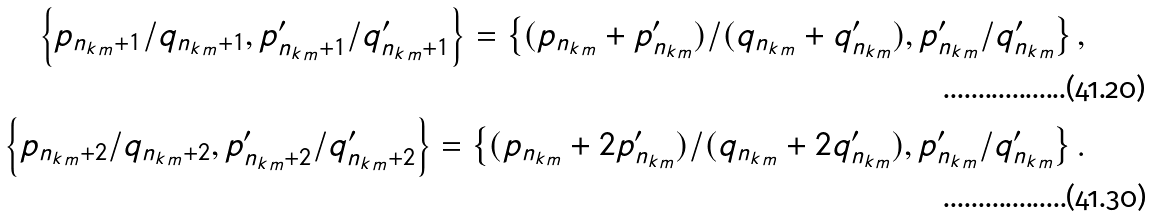Convert formula to latex. <formula><loc_0><loc_0><loc_500><loc_500>\left \{ p _ { { n _ { k } } _ { m } + 1 } / q _ { { n _ { k } } _ { m } + 1 } , p ^ { \prime } _ { { n _ { k } } _ { m } + 1 } / q ^ { \prime } _ { { n _ { k } } _ { m } + 1 } \right \} = \left \{ ( p _ { { n _ { k } } _ { m } } + p ^ { \prime } _ { { n _ { k } } _ { m } } ) / ( q _ { { n _ { k } } _ { m } } + q ^ { \prime } _ { { n _ { k } } _ { m } } ) , p ^ { \prime } _ { { n _ { k } } _ { m } } / q ^ { \prime } _ { { n _ { k } } _ { m } } \right \} , \\ \left \{ p _ { { n _ { k } } _ { m } + 2 } / q _ { { n _ { k } } _ { m } + 2 } , p ^ { \prime } _ { { n _ { k } } _ { m } + 2 } / q ^ { \prime } _ { { n _ { k } } _ { m } + 2 } \right \} = \left \{ ( p _ { { n _ { k } } _ { m } } + 2 p ^ { \prime } _ { { n _ { k } } _ { m } } ) / ( q _ { { n _ { k } } _ { m } } + 2 q ^ { \prime } _ { { n _ { k } } _ { m } } ) , p ^ { \prime } _ { { n _ { k } } _ { m } } / q ^ { \prime } _ { { n _ { k } } _ { m } } \right \} .</formula> 